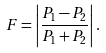<formula> <loc_0><loc_0><loc_500><loc_500>F = \left | \frac { P _ { 1 } - P _ { 2 } } { P _ { 1 } + P _ { 2 } } \right | .</formula> 